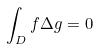<formula> <loc_0><loc_0><loc_500><loc_500>\int _ { D } f \Delta g = 0</formula> 